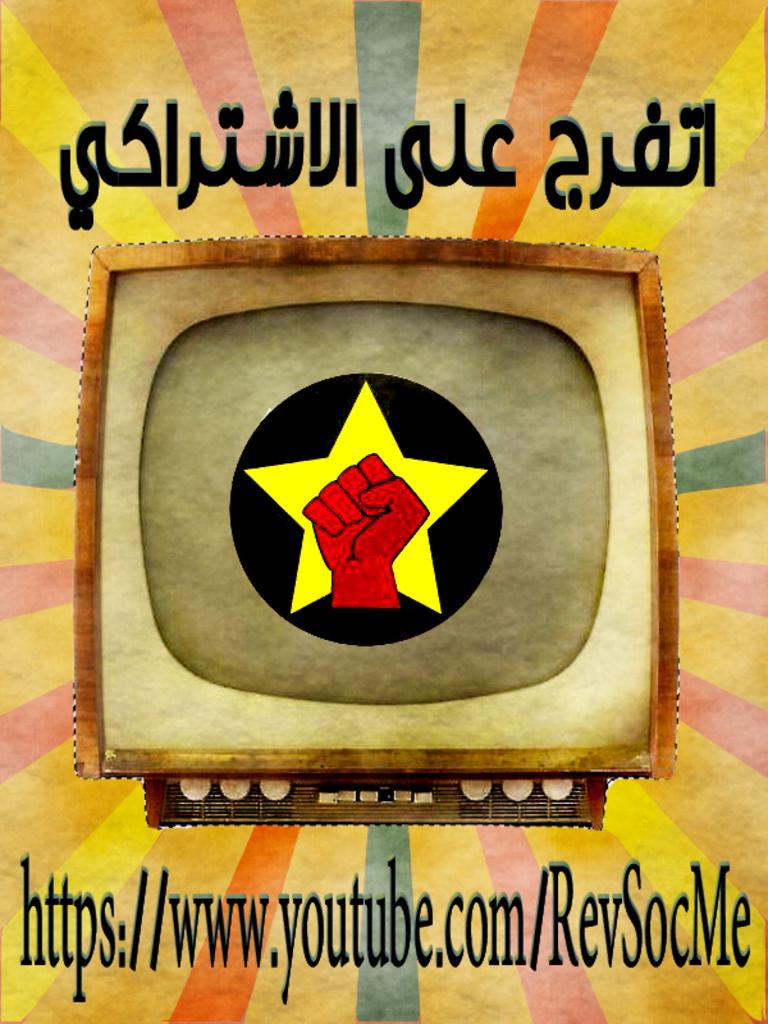What site should you visit ?
Make the answer very short. Https://www.youtube.com/revsocme. What is the website on the picture?
Your answer should be compact. Https://www.youtube.com/revsocme. 